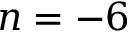<formula> <loc_0><loc_0><loc_500><loc_500>n = - 6</formula> 